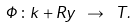Convert formula to latex. <formula><loc_0><loc_0><loc_500><loc_500>\Phi \colon k + R y \ \rightarrow \ T .</formula> 